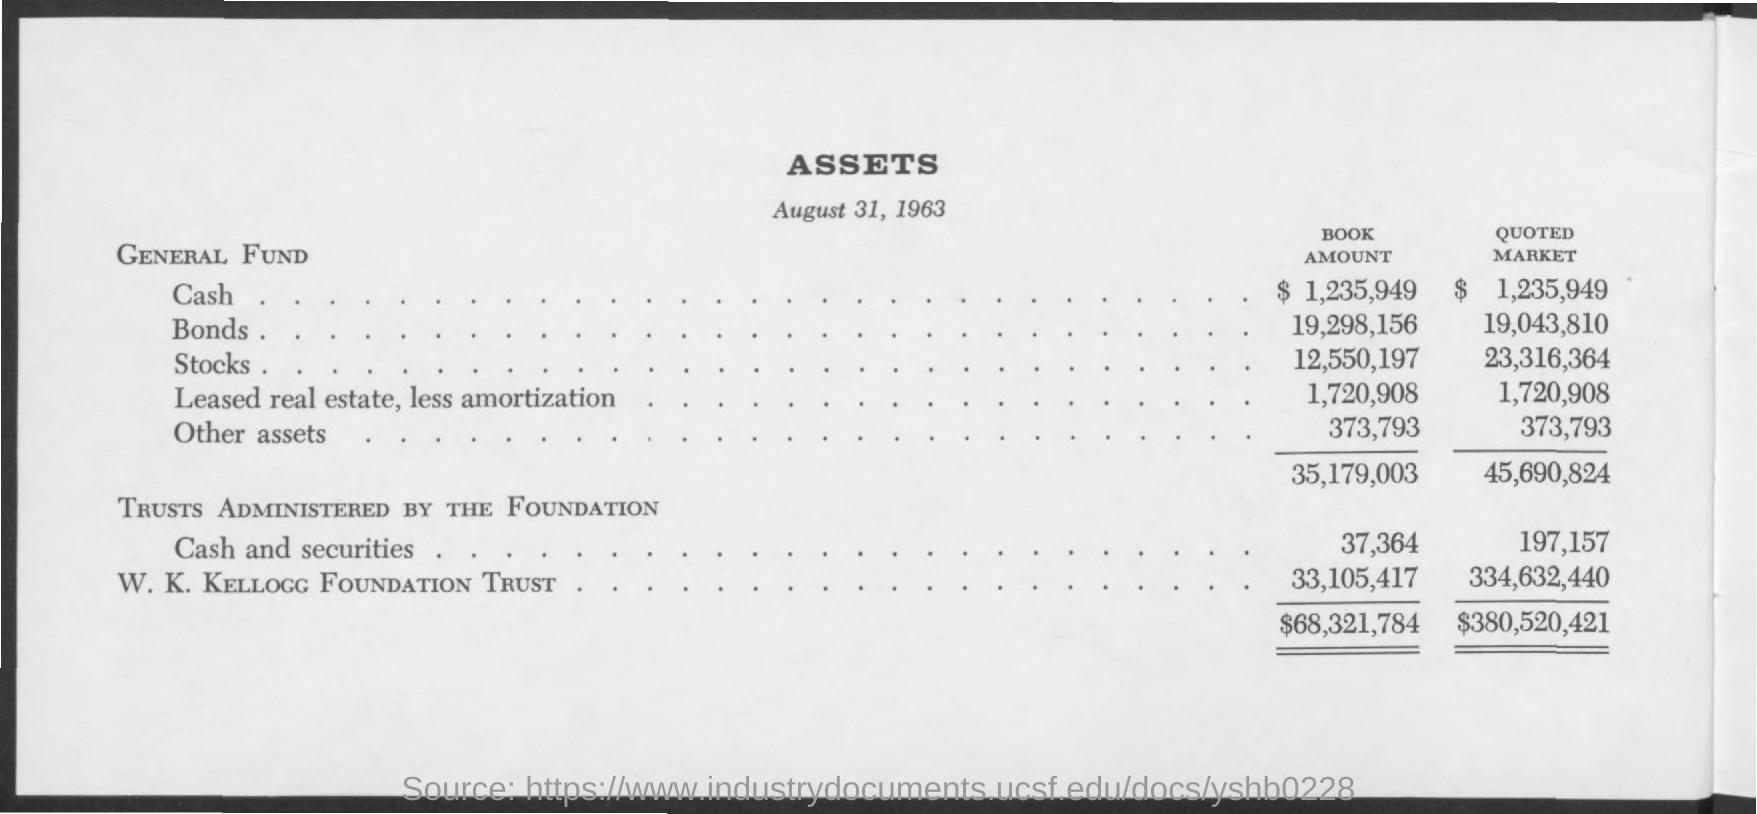What is the title of the document?
Make the answer very short. Assets. What is the date of this assets report?
Make the answer very short. August 31, 1963. 